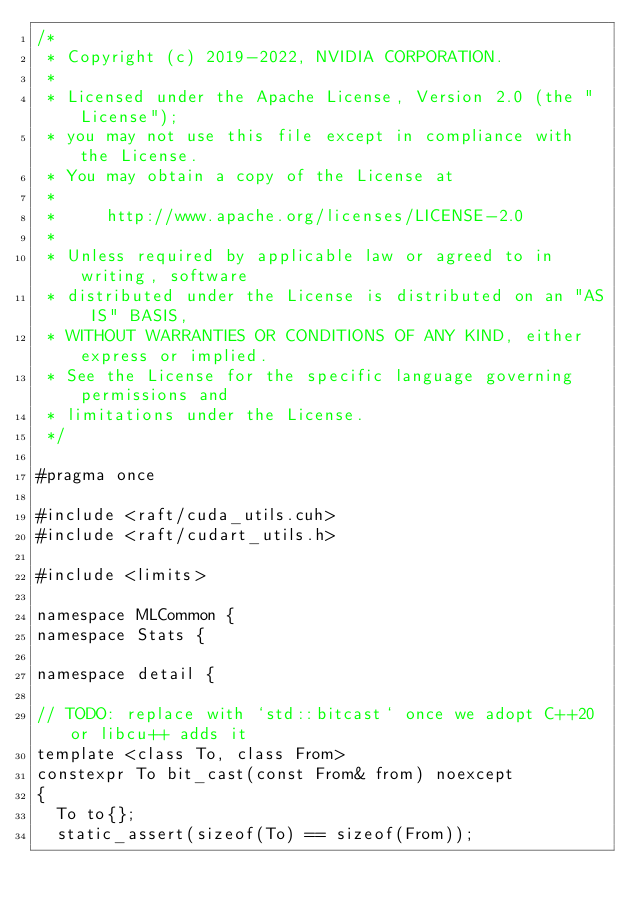Convert code to text. <code><loc_0><loc_0><loc_500><loc_500><_Cuda_>/*
 * Copyright (c) 2019-2022, NVIDIA CORPORATION.
 *
 * Licensed under the Apache License, Version 2.0 (the "License");
 * you may not use this file except in compliance with the License.
 * You may obtain a copy of the License at
 *
 *     http://www.apache.org/licenses/LICENSE-2.0
 *
 * Unless required by applicable law or agreed to in writing, software
 * distributed under the License is distributed on an "AS IS" BASIS,
 * WITHOUT WARRANTIES OR CONDITIONS OF ANY KIND, either express or implied.
 * See the License for the specific language governing permissions and
 * limitations under the License.
 */

#pragma once

#include <raft/cuda_utils.cuh>
#include <raft/cudart_utils.h>

#include <limits>

namespace MLCommon {
namespace Stats {

namespace detail {

// TODO: replace with `std::bitcast` once we adopt C++20 or libcu++ adds it
template <class To, class From>
constexpr To bit_cast(const From& from) noexcept
{
  To to{};
  static_assert(sizeof(To) == sizeof(From));</code> 